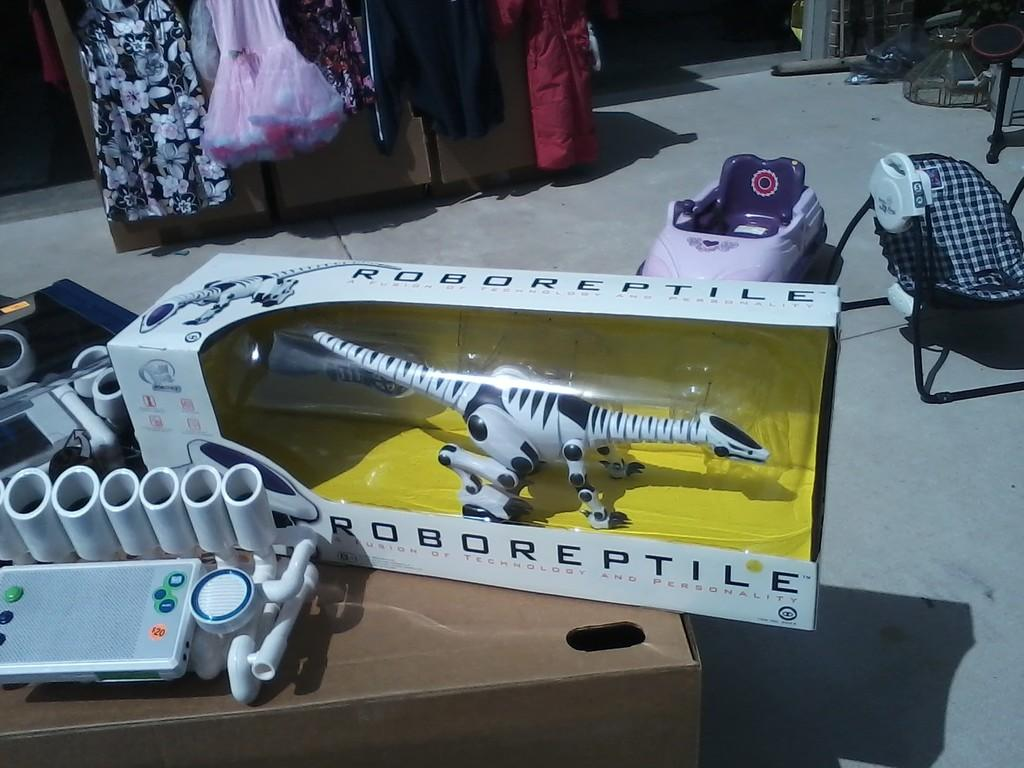<image>
Describe the image concisely. A toy called Robo Reptile in it's packaging 